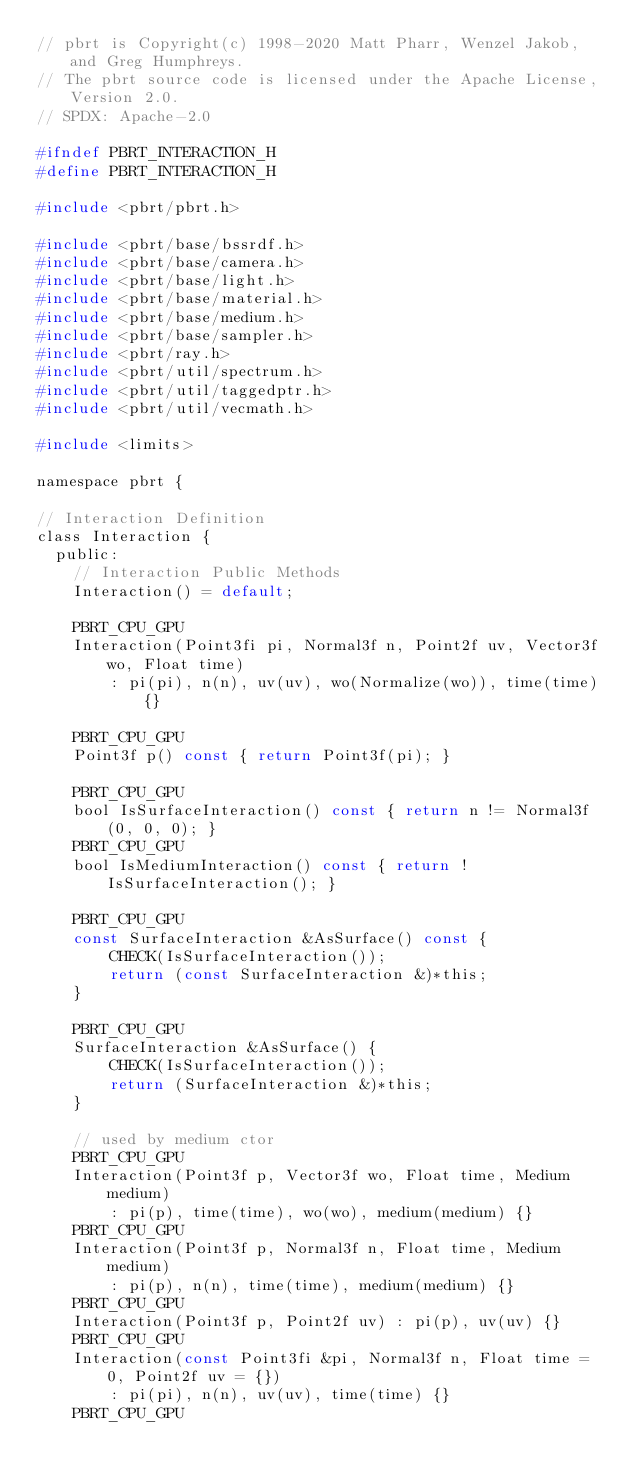Convert code to text. <code><loc_0><loc_0><loc_500><loc_500><_C_>// pbrt is Copyright(c) 1998-2020 Matt Pharr, Wenzel Jakob, and Greg Humphreys.
// The pbrt source code is licensed under the Apache License, Version 2.0.
// SPDX: Apache-2.0

#ifndef PBRT_INTERACTION_H
#define PBRT_INTERACTION_H

#include <pbrt/pbrt.h>

#include <pbrt/base/bssrdf.h>
#include <pbrt/base/camera.h>
#include <pbrt/base/light.h>
#include <pbrt/base/material.h>
#include <pbrt/base/medium.h>
#include <pbrt/base/sampler.h>
#include <pbrt/ray.h>
#include <pbrt/util/spectrum.h>
#include <pbrt/util/taggedptr.h>
#include <pbrt/util/vecmath.h>

#include <limits>

namespace pbrt {

// Interaction Definition
class Interaction {
  public:
    // Interaction Public Methods
    Interaction() = default;

    PBRT_CPU_GPU
    Interaction(Point3fi pi, Normal3f n, Point2f uv, Vector3f wo, Float time)
        : pi(pi), n(n), uv(uv), wo(Normalize(wo)), time(time) {}

    PBRT_CPU_GPU
    Point3f p() const { return Point3f(pi); }

    PBRT_CPU_GPU
    bool IsSurfaceInteraction() const { return n != Normal3f(0, 0, 0); }
    PBRT_CPU_GPU
    bool IsMediumInteraction() const { return !IsSurfaceInteraction(); }

    PBRT_CPU_GPU
    const SurfaceInteraction &AsSurface() const {
        CHECK(IsSurfaceInteraction());
        return (const SurfaceInteraction &)*this;
    }

    PBRT_CPU_GPU
    SurfaceInteraction &AsSurface() {
        CHECK(IsSurfaceInteraction());
        return (SurfaceInteraction &)*this;
    }

    // used by medium ctor
    PBRT_CPU_GPU
    Interaction(Point3f p, Vector3f wo, Float time, Medium medium)
        : pi(p), time(time), wo(wo), medium(medium) {}
    PBRT_CPU_GPU
    Interaction(Point3f p, Normal3f n, Float time, Medium medium)
        : pi(p), n(n), time(time), medium(medium) {}
    PBRT_CPU_GPU
    Interaction(Point3f p, Point2f uv) : pi(p), uv(uv) {}
    PBRT_CPU_GPU
    Interaction(const Point3fi &pi, Normal3f n, Float time = 0, Point2f uv = {})
        : pi(pi), n(n), uv(uv), time(time) {}
    PBRT_CPU_GPU</code> 